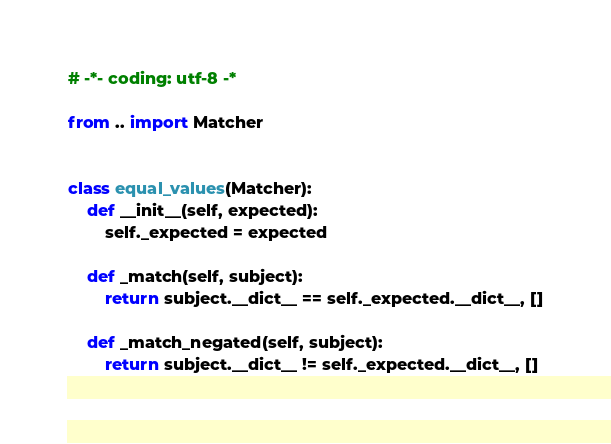Convert code to text. <code><loc_0><loc_0><loc_500><loc_500><_Python_># -*- coding: utf-8 -*

from .. import Matcher


class equal_values(Matcher):
    def __init__(self, expected):
        self._expected = expected

    def _match(self, subject):
        return subject.__dict__ == self._expected.__dict__, []

    def _match_negated(self, subject):
        return subject.__dict__ != self._expected.__dict__, []
</code> 